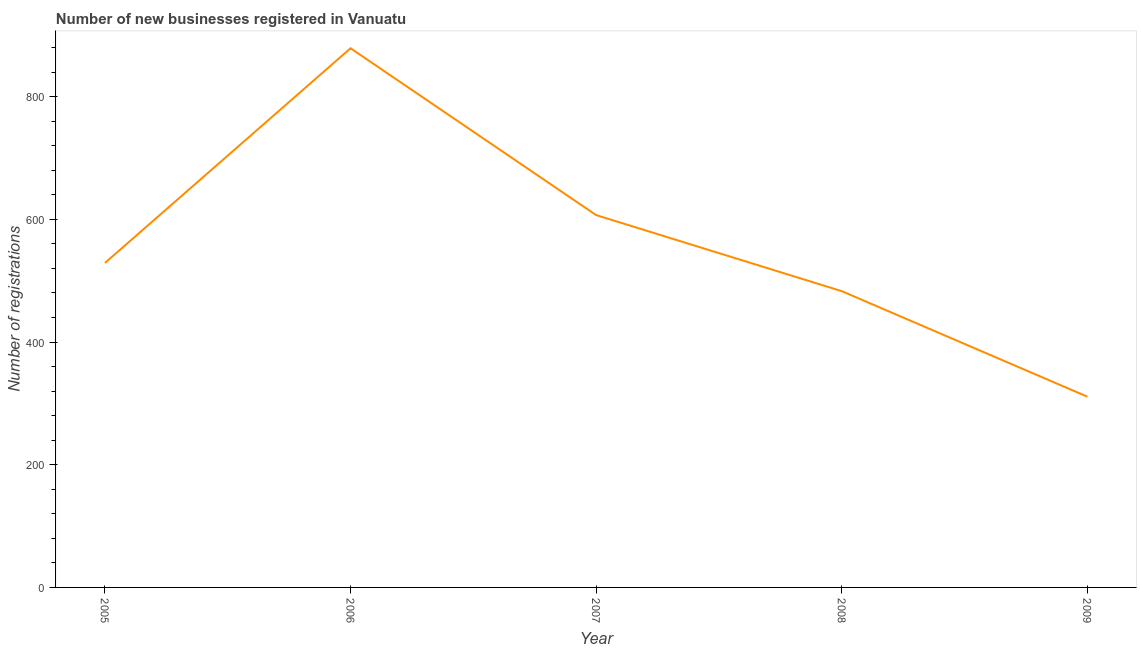What is the number of new business registrations in 2008?
Ensure brevity in your answer.  483. Across all years, what is the maximum number of new business registrations?
Offer a very short reply. 879. Across all years, what is the minimum number of new business registrations?
Keep it short and to the point. 311. In which year was the number of new business registrations maximum?
Provide a succinct answer. 2006. What is the sum of the number of new business registrations?
Make the answer very short. 2809. What is the difference between the number of new business registrations in 2005 and 2006?
Keep it short and to the point. -350. What is the average number of new business registrations per year?
Give a very brief answer. 561.8. What is the median number of new business registrations?
Your answer should be compact. 529. In how many years, is the number of new business registrations greater than 320 ?
Keep it short and to the point. 4. What is the ratio of the number of new business registrations in 2005 to that in 2006?
Provide a short and direct response. 0.6. Is the difference between the number of new business registrations in 2008 and 2009 greater than the difference between any two years?
Your answer should be compact. No. What is the difference between the highest and the second highest number of new business registrations?
Provide a short and direct response. 272. Is the sum of the number of new business registrations in 2008 and 2009 greater than the maximum number of new business registrations across all years?
Ensure brevity in your answer.  No. What is the difference between the highest and the lowest number of new business registrations?
Offer a terse response. 568. In how many years, is the number of new business registrations greater than the average number of new business registrations taken over all years?
Your response must be concise. 2. Does the number of new business registrations monotonically increase over the years?
Ensure brevity in your answer.  No. How many years are there in the graph?
Your answer should be very brief. 5. Are the values on the major ticks of Y-axis written in scientific E-notation?
Your answer should be very brief. No. Does the graph contain any zero values?
Offer a terse response. No. What is the title of the graph?
Your response must be concise. Number of new businesses registered in Vanuatu. What is the label or title of the X-axis?
Offer a terse response. Year. What is the label or title of the Y-axis?
Your answer should be compact. Number of registrations. What is the Number of registrations in 2005?
Offer a very short reply. 529. What is the Number of registrations of 2006?
Give a very brief answer. 879. What is the Number of registrations in 2007?
Your answer should be compact. 607. What is the Number of registrations of 2008?
Offer a terse response. 483. What is the Number of registrations in 2009?
Give a very brief answer. 311. What is the difference between the Number of registrations in 2005 and 2006?
Your answer should be compact. -350. What is the difference between the Number of registrations in 2005 and 2007?
Make the answer very short. -78. What is the difference between the Number of registrations in 2005 and 2008?
Make the answer very short. 46. What is the difference between the Number of registrations in 2005 and 2009?
Your answer should be compact. 218. What is the difference between the Number of registrations in 2006 and 2007?
Keep it short and to the point. 272. What is the difference between the Number of registrations in 2006 and 2008?
Ensure brevity in your answer.  396. What is the difference between the Number of registrations in 2006 and 2009?
Your answer should be very brief. 568. What is the difference between the Number of registrations in 2007 and 2008?
Give a very brief answer. 124. What is the difference between the Number of registrations in 2007 and 2009?
Offer a very short reply. 296. What is the difference between the Number of registrations in 2008 and 2009?
Offer a terse response. 172. What is the ratio of the Number of registrations in 2005 to that in 2006?
Your answer should be compact. 0.6. What is the ratio of the Number of registrations in 2005 to that in 2007?
Offer a terse response. 0.87. What is the ratio of the Number of registrations in 2005 to that in 2008?
Your response must be concise. 1.09. What is the ratio of the Number of registrations in 2005 to that in 2009?
Provide a succinct answer. 1.7. What is the ratio of the Number of registrations in 2006 to that in 2007?
Give a very brief answer. 1.45. What is the ratio of the Number of registrations in 2006 to that in 2008?
Your answer should be compact. 1.82. What is the ratio of the Number of registrations in 2006 to that in 2009?
Provide a short and direct response. 2.83. What is the ratio of the Number of registrations in 2007 to that in 2008?
Offer a very short reply. 1.26. What is the ratio of the Number of registrations in 2007 to that in 2009?
Offer a very short reply. 1.95. What is the ratio of the Number of registrations in 2008 to that in 2009?
Ensure brevity in your answer.  1.55. 